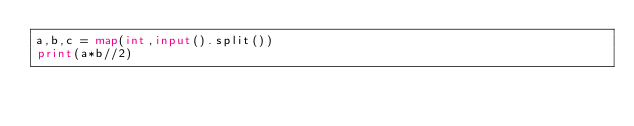<code> <loc_0><loc_0><loc_500><loc_500><_Python_>a,b,c = map(int,input().split())
print(a*b//2)
</code> 